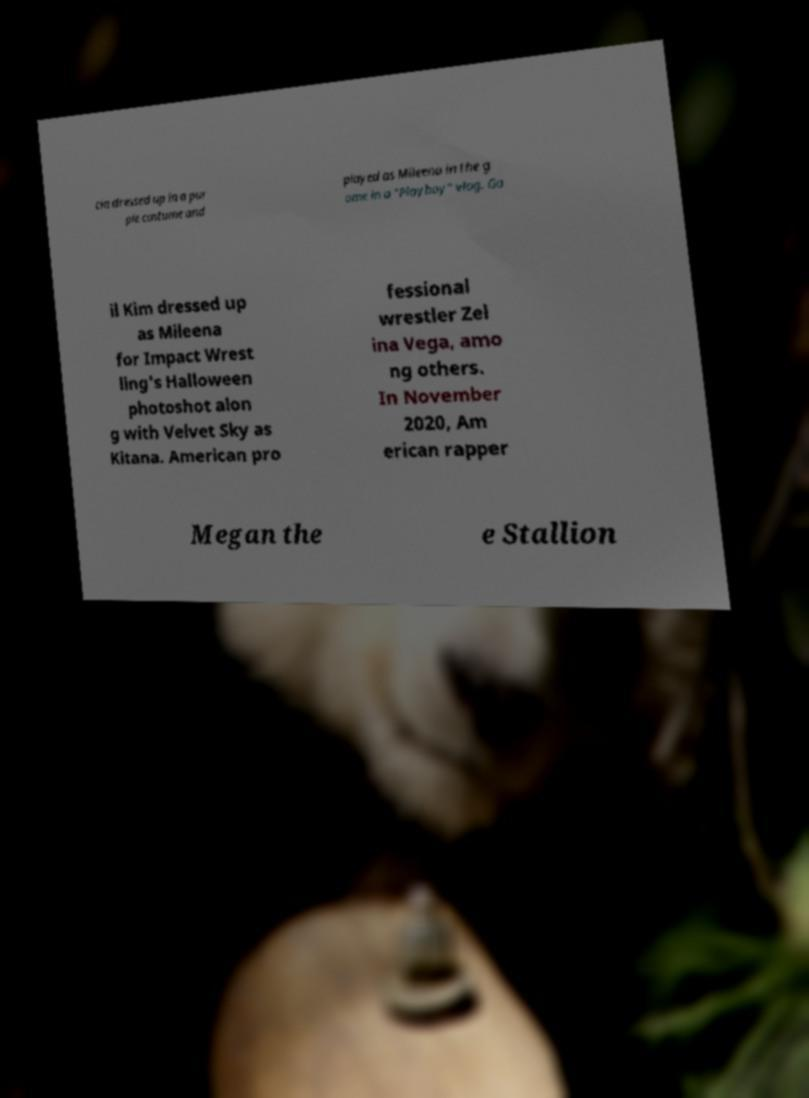Could you extract and type out the text from this image? cia dressed up in a pur ple costume and played as Mileena in the g ame in a "Playboy" vlog. Ga il Kim dressed up as Mileena for Impact Wrest ling's Halloween photoshot alon g with Velvet Sky as Kitana. American pro fessional wrestler Zel ina Vega, amo ng others. In November 2020, Am erican rapper Megan the e Stallion 